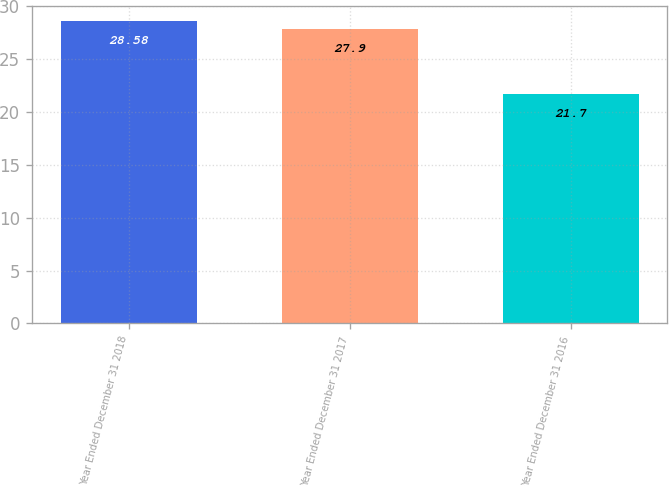<chart> <loc_0><loc_0><loc_500><loc_500><bar_chart><fcel>Year Ended December 31 2018<fcel>Year Ended December 31 2017<fcel>Year Ended December 31 2016<nl><fcel>28.58<fcel>27.9<fcel>21.7<nl></chart> 